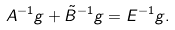Convert formula to latex. <formula><loc_0><loc_0><loc_500><loc_500>A ^ { - 1 } g + \tilde { B } ^ { - 1 } g = E ^ { - 1 } g .</formula> 